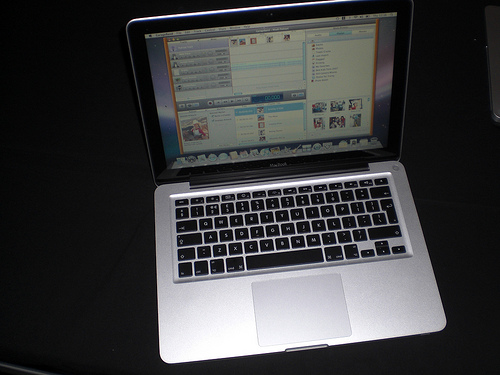<image>
Can you confirm if the monitor is on the keyboard? Yes. Looking at the image, I can see the monitor is positioned on top of the keyboard, with the keyboard providing support. 